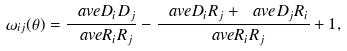<formula> <loc_0><loc_0><loc_500><loc_500>\omega _ { i j } ( \theta ) = \frac { \ a v e { D _ { i } D _ { j } } } { \ a v e { R _ { i } R _ { j } } } - \frac { \ a v e { D _ { i } R _ { j } } + \ a v e { D _ { j } R _ { i } } } { \ a v e { R _ { i } R _ { j } } } + 1 \, ,</formula> 